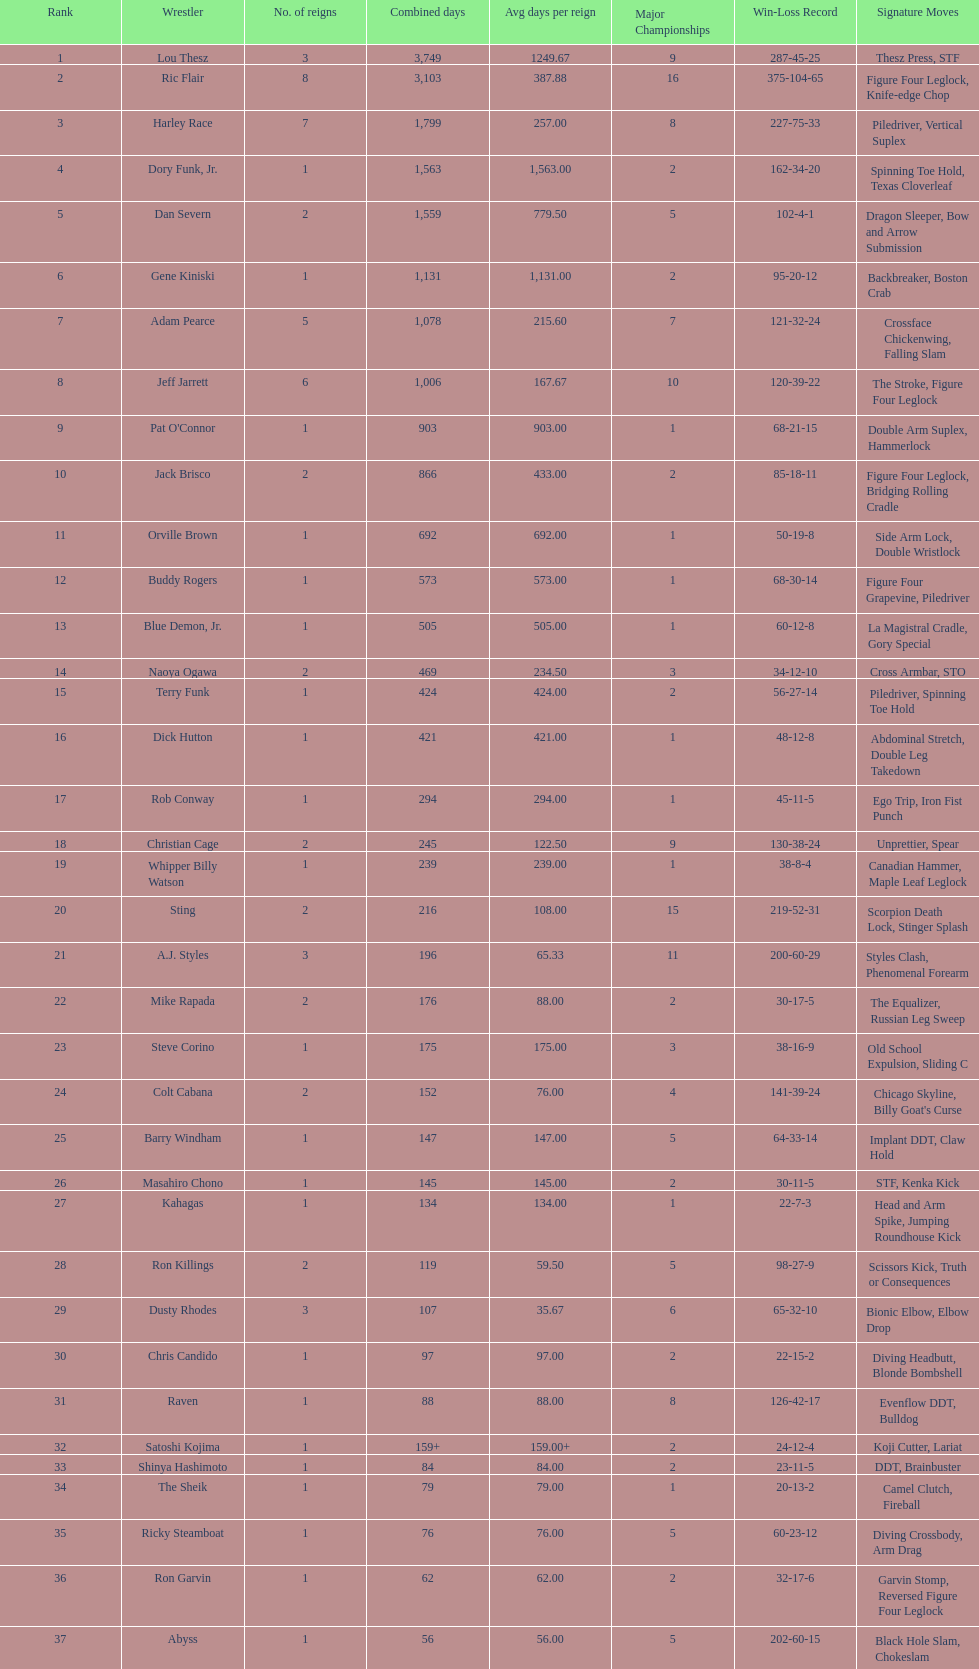Help me parse the entirety of this table. {'header': ['Rank', 'Wrestler', 'No. of reigns', 'Combined days', 'Avg days per reign', 'Major Championships', 'Win-Loss Record', 'Signature Moves'], 'rows': [['1', 'Lou Thesz', '3', '3,749', '1249.67', '9', '287-45-25', 'Thesz Press, STF'], ['2', 'Ric Flair', '8', '3,103', '387.88', '16', '375-104-65', 'Figure Four Leglock, Knife-edge Chop'], ['3', 'Harley Race', '7', '1,799', '257.00', '8', '227-75-33', 'Piledriver, Vertical Suplex'], ['4', 'Dory Funk, Jr.', '1', '1,563', '1,563.00', '2', '162-34-20', 'Spinning Toe Hold, Texas Cloverleaf'], ['5', 'Dan Severn', '2', '1,559', '779.50', '5', '102-4-1', 'Dragon Sleeper, Bow and Arrow Submission'], ['6', 'Gene Kiniski', '1', '1,131', '1,131.00', '2', '95-20-12', 'Backbreaker, Boston Crab'], ['7', 'Adam Pearce', '5', '1,078', '215.60', '7', '121-32-24', 'Crossface Chickenwing, Falling Slam'], ['8', 'Jeff Jarrett', '6', '1,006', '167.67', '10', '120-39-22', 'The Stroke, Figure Four Leglock'], ['9', "Pat O'Connor", '1', '903', '903.00', '1', '68-21-15', 'Double Arm Suplex, Hammerlock'], ['10', 'Jack Brisco', '2', '866', '433.00', '2', '85-18-11', 'Figure Four Leglock, Bridging Rolling Cradle'], ['11', 'Orville Brown', '1', '692', '692.00', '1', '50-19-8', 'Side Arm Lock, Double Wristlock'], ['12', 'Buddy Rogers', '1', '573', '573.00', '1', '68-30-14', 'Figure Four Grapevine, Piledriver'], ['13', 'Blue Demon, Jr.', '1', '505', '505.00', '1', '60-12-8', 'La Magistral Cradle, Gory Special'], ['14', 'Naoya Ogawa', '2', '469', '234.50', '3', '34-12-10', 'Cross Armbar, STO'], ['15', 'Terry Funk', '1', '424', '424.00', '2', '56-27-14', 'Piledriver, Spinning Toe Hold'], ['16', 'Dick Hutton', '1', '421', '421.00', '1', '48-12-8', 'Abdominal Stretch, Double Leg Takedown'], ['17', 'Rob Conway', '1', '294', '294.00', '1', '45-11-5', 'Ego Trip, Iron Fist Punch'], ['18', 'Christian Cage', '2', '245', '122.50', '9', '130-38-24', 'Unprettier, Spear'], ['19', 'Whipper Billy Watson', '1', '239', '239.00', '1', '38-8-4', 'Canadian Hammer, Maple Leaf Leglock'], ['20', 'Sting', '2', '216', '108.00', '15', '219-52-31', 'Scorpion Death Lock, Stinger Splash'], ['21', 'A.J. Styles', '3', '196', '65.33', '11', '200-60-29', 'Styles Clash, Phenomenal Forearm'], ['22', 'Mike Rapada', '2', '176', '88.00', '2', '30-17-5', 'The Equalizer, Russian Leg Sweep'], ['23', 'Steve Corino', '1', '175', '175.00', '3', '38-16-9', 'Old School Expulsion, Sliding C'], ['24', 'Colt Cabana', '2', '152', '76.00', '4', '141-39-24', "Chicago Skyline, Billy Goat's Curse"], ['25', 'Barry Windham', '1', '147', '147.00', '5', '64-33-14', 'Implant DDT, Claw Hold'], ['26', 'Masahiro Chono', '1', '145', '145.00', '2', '30-11-5', 'STF, Kenka Kick'], ['27', 'Kahagas', '1', '134', '134.00', '1', '22-7-3', 'Head and Arm Spike, Jumping Roundhouse Kick'], ['28', 'Ron Killings', '2', '119', '59.50', '5', '98-27-9', 'Scissors Kick, Truth or Consequences'], ['29', 'Dusty Rhodes', '3', '107', '35.67', '6', '65-32-10', 'Bionic Elbow, Elbow Drop'], ['30', 'Chris Candido', '1', '97', '97.00', '2', '22-15-2', 'Diving Headbutt, Blonde Bombshell'], ['31', 'Raven', '1', '88', '88.00', '8', '126-42-17', 'Evenflow DDT, Bulldog'], ['32', 'Satoshi Kojima', '1', '159+', '159.00+', '2', '24-12-4', 'Koji Cutter, Lariat'], ['33', 'Shinya Hashimoto', '1', '84', '84.00', '2', '23-11-5', 'DDT, Brainbuster'], ['34', 'The Sheik', '1', '79', '79.00', '1', '20-13-2', 'Camel Clutch, Fireball'], ['35', 'Ricky Steamboat', '1', '76', '76.00', '5', '60-23-12', 'Diving Crossbody, Arm Drag'], ['36', 'Ron Garvin', '1', '62', '62.00', '2', '32-17-6', 'Garvin Stomp, Reversed Figure Four Leglock'], ['37', 'Abyss', '1', '56', '56.00', '5', '202-60-15', 'Black Hole Slam, Chokeslam'], ['39', 'Ken Shamrock', '1', '49', '49.00', '3', '24-13-4', 'Ankle Lock, Belly-to-belly Suplex'], ['39', 'Brent Albright', '1', '49', '49.00', '1', '20-14-3', 'Half Nelson Suplex, Crowbar'], ['40', 'The Great Muta', '1', '48', '48.00', '8', '89-22-13', 'Shining Wizard, Moonsault'], ['41', 'Sabu', '1', '38', '38.00', '5', '99-45-17', 'Triple Jump Moonsault, Arabian Facebuster'], ['42', 'Giant Baba', '3', '19', '6.33', '6', '68-23-9', 'Russian Bear Hug, Baba Chop'], ['43', 'Kerry Von Erich', '1', '18', '18.00', '1', '12-8-1', 'Iron Claw, Tornado Punch'], ['44', 'Gary Steele', '1', '7', '7.00', '1', '3-2-1', 'Tower of London, Tiger Bomb'], ['45', 'Tommy Rich', '1', '4', '4.00', '3', '21-14-7', 'Thesz Press, Lou Thesz Press'], ['46', 'Rhino', '1', '2', '2.00', '4', '41-23-6', 'Gore, Piledriver'], ['47', 'Shane Douglas', '1', '<1', '<1.00', '4', '45-34-9', 'Belly-to-Belly Suplex, Pittsburgh Plunge']]} How long did orville brown remain nwa world heavyweight champion? 692 days. 